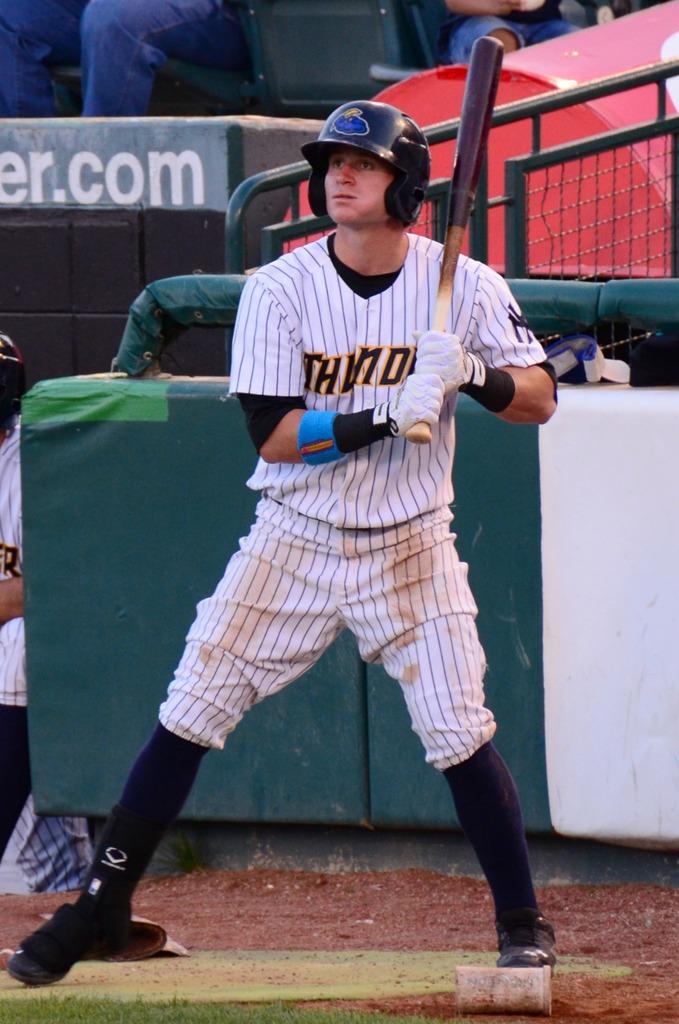What game is being played?
Your answer should be very brief. Answering does not require reading text in the image. What is the team's name?
Provide a succinct answer. Thunder. 